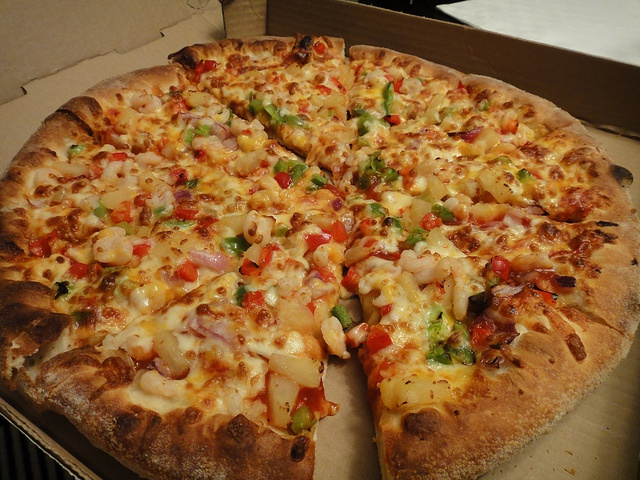Describe the objects in this image and their specific colors. I can see a pizza in brown, olive, maroon, and tan tones in this image. 